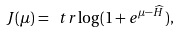Convert formula to latex. <formula><loc_0><loc_0><loc_500><loc_500>J ( \mu ) = \ t r \log ( 1 + e ^ { \mu - \widehat { H } } ) ,</formula> 